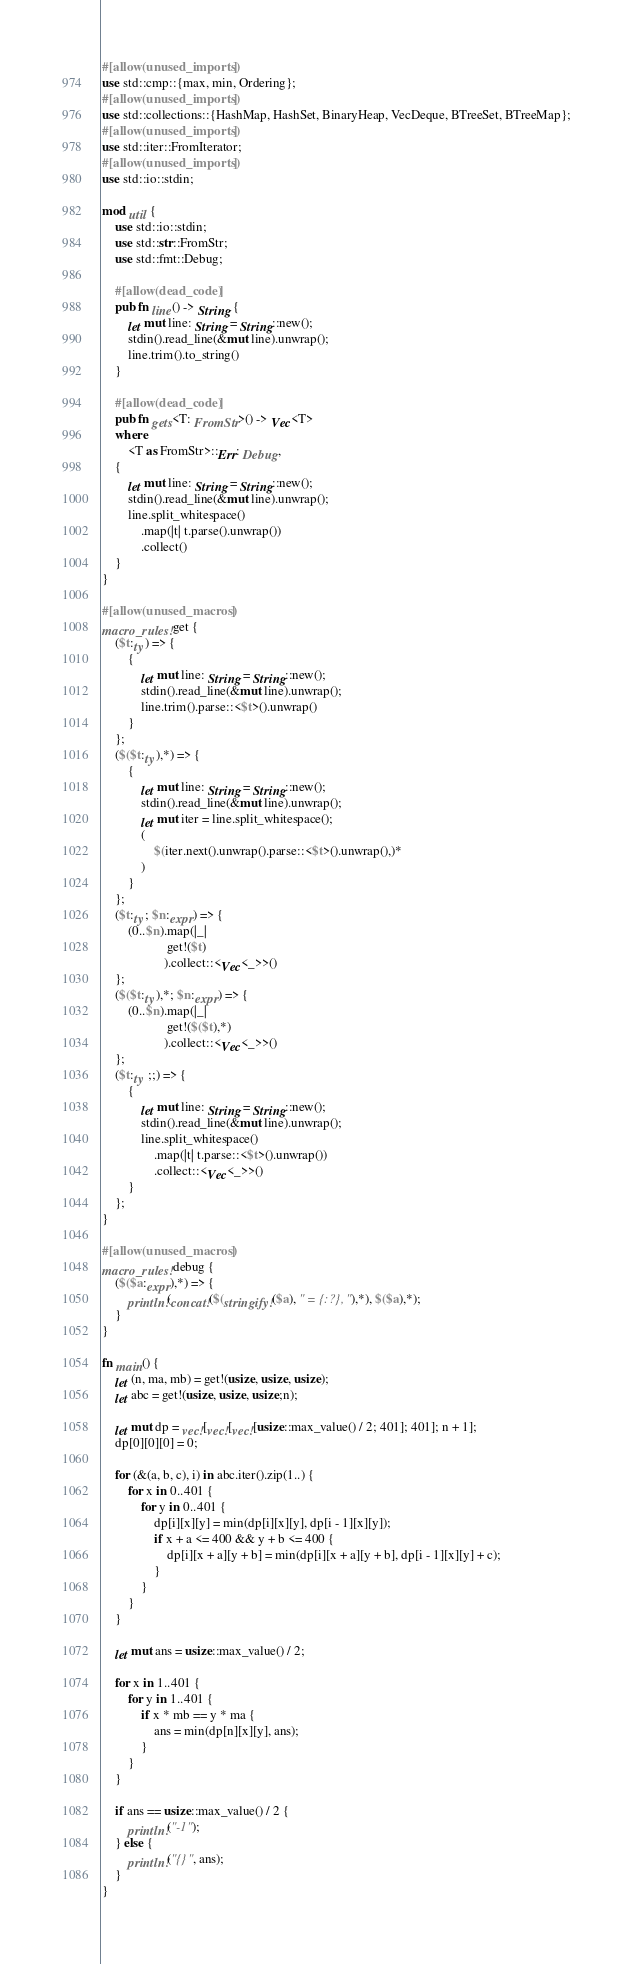<code> <loc_0><loc_0><loc_500><loc_500><_Rust_>#[allow(unused_imports)]
use std::cmp::{max, min, Ordering};
#[allow(unused_imports)]
use std::collections::{HashMap, HashSet, BinaryHeap, VecDeque, BTreeSet, BTreeMap};
#[allow(unused_imports)]
use std::iter::FromIterator;
#[allow(unused_imports)]
use std::io::stdin;

mod util {
    use std::io::stdin;
    use std::str::FromStr;
    use std::fmt::Debug;

    #[allow(dead_code)]
    pub fn line() -> String {
        let mut line: String = String::new();
        stdin().read_line(&mut line).unwrap();
        line.trim().to_string()
    }

    #[allow(dead_code)]
    pub fn gets<T: FromStr>() -> Vec<T>
    where
        <T as FromStr>::Err: Debug,
    {
        let mut line: String = String::new();
        stdin().read_line(&mut line).unwrap();
        line.split_whitespace()
            .map(|t| t.parse().unwrap())
            .collect()
    }
}

#[allow(unused_macros)]
macro_rules! get {
    ($t:ty) => {
        {
            let mut line: String = String::new();
            stdin().read_line(&mut line).unwrap();
            line.trim().parse::<$t>().unwrap()
        }
    };
    ($($t:ty),*) => {
        {
            let mut line: String = String::new();
            stdin().read_line(&mut line).unwrap();
            let mut iter = line.split_whitespace();
            (
                $(iter.next().unwrap().parse::<$t>().unwrap(),)*
            )
        }
    };
    ($t:ty; $n:expr) => {
        (0..$n).map(|_|
                    get!($t)
                   ).collect::<Vec<_>>()
    };
    ($($t:ty),*; $n:expr) => {
        (0..$n).map(|_|
                    get!($($t),*)
                   ).collect::<Vec<_>>()
    };
    ($t:ty ;;) => {
        {
            let mut line: String = String::new();
            stdin().read_line(&mut line).unwrap();
            line.split_whitespace()
                .map(|t| t.parse::<$t>().unwrap())
                .collect::<Vec<_>>()
        }
    };
}

#[allow(unused_macros)]
macro_rules! debug {
    ($($a:expr),*) => {
        println!(concat!($(stringify!($a), " = {:?}, "),*), $($a),*);
    }
}

fn main() {
    let (n, ma, mb) = get!(usize, usize, usize);
    let abc = get!(usize, usize, usize;n);

    let mut dp = vec![vec![vec![usize::max_value() / 2; 401]; 401]; n + 1];
    dp[0][0][0] = 0;

    for (&(a, b, c), i) in abc.iter().zip(1..) {
        for x in 0..401 {
            for y in 0..401 {
                dp[i][x][y] = min(dp[i][x][y], dp[i - 1][x][y]);
                if x + a <= 400 && y + b <= 400 {
                    dp[i][x + a][y + b] = min(dp[i][x + a][y + b], dp[i - 1][x][y] + c);
                }
            }
        }
    }

    let mut ans = usize::max_value() / 2;

    for x in 1..401 {
        for y in 1..401 {
            if x * mb == y * ma {
                ans = min(dp[n][x][y], ans);
            }
        }
    }

    if ans == usize::max_value() / 2 {
        println!("-1");
    } else {
        println!("{}", ans);
    }
}
</code> 